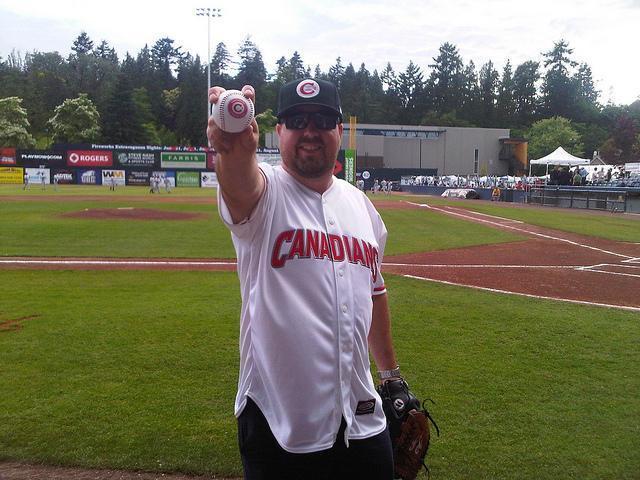How many people are visible?
Give a very brief answer. 2. 